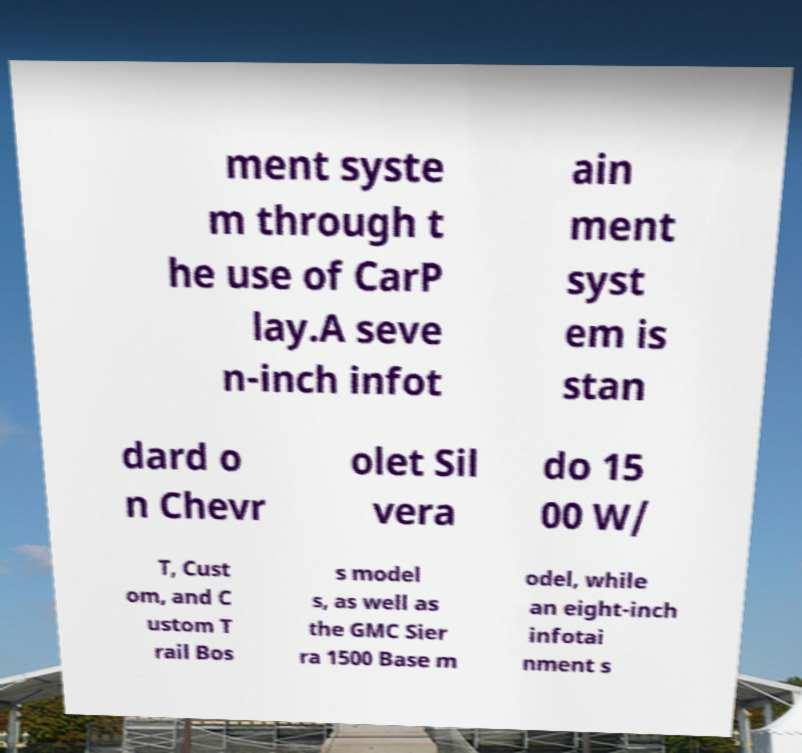Could you assist in decoding the text presented in this image and type it out clearly? ment syste m through t he use of CarP lay.A seve n-inch infot ain ment syst em is stan dard o n Chevr olet Sil vera do 15 00 W/ T, Cust om, and C ustom T rail Bos s model s, as well as the GMC Sier ra 1500 Base m odel, while an eight-inch infotai nment s 